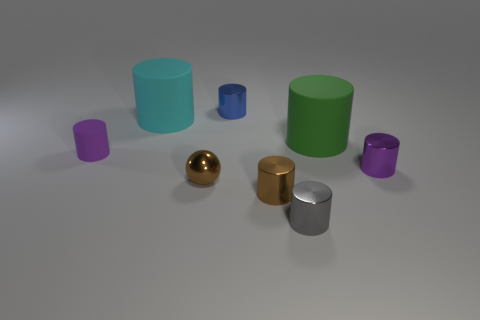Are there any objects in the scene that seem out of place? All objects share a simplistic geometric form, which creates a cohesive scene. However, relative to the matte finish of others, the shiny surfaces of the gold and silver objects make them stand out. How do these objects differ in terms of their surfaces? Most objects have a matte surface which diffuses light, providing a soft appearance. In contrast, the gold and silver objects have a mirror-like reflective surface, giving them a distinct shine and clear reflections. 